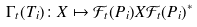Convert formula to latex. <formula><loc_0><loc_0><loc_500><loc_500>\Gamma _ { t } ( T _ { i } ) \colon X \mapsto \mathcal { F } _ { t } ( P _ { i } ) X \mathcal { F } _ { t } ( P _ { i } ) ^ { * }</formula> 